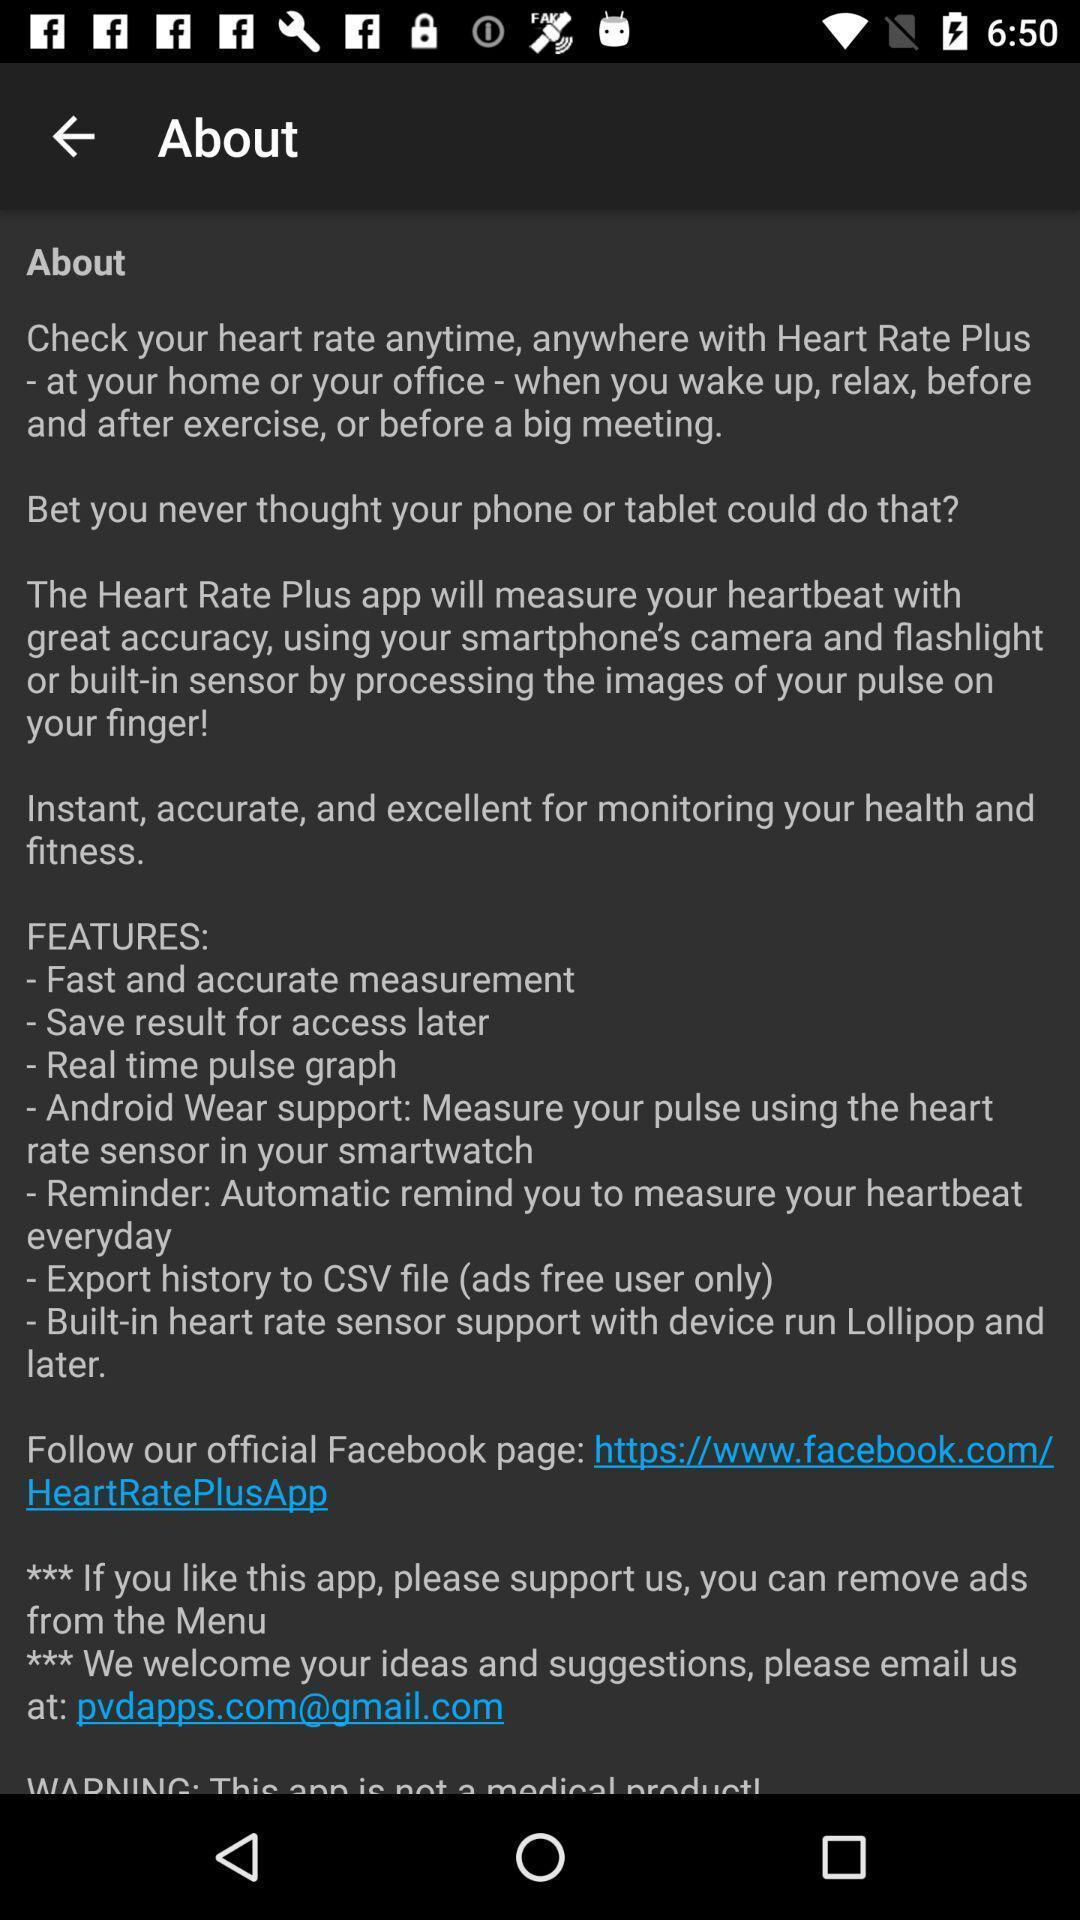Give me a summary of this screen capture. Screen page displaying an information in health application. 